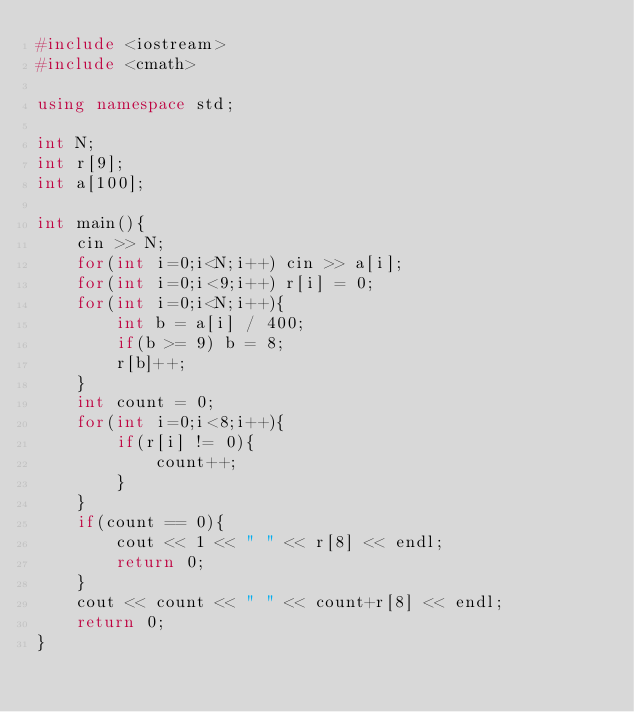<code> <loc_0><loc_0><loc_500><loc_500><_C++_>#include <iostream>
#include <cmath>

using namespace std;

int N;
int r[9];
int a[100];

int main(){
    cin >> N;
    for(int i=0;i<N;i++) cin >> a[i];
    for(int i=0;i<9;i++) r[i] = 0;
    for(int i=0;i<N;i++){
        int b = a[i] / 400;
        if(b >= 9) b = 8;
        r[b]++;
    }
    int count = 0;
    for(int i=0;i<8;i++){
        if(r[i] != 0){
            count++;
        }
    }
    if(count == 0){
        cout << 1 << " " << r[8] << endl;
        return 0;
    }
    cout << count << " " << count+r[8] << endl;
    return 0;
}</code> 